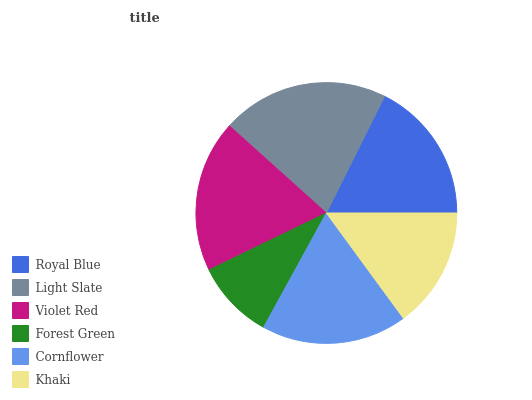Is Forest Green the minimum?
Answer yes or no. Yes. Is Light Slate the maximum?
Answer yes or no. Yes. Is Violet Red the minimum?
Answer yes or no. No. Is Violet Red the maximum?
Answer yes or no. No. Is Light Slate greater than Violet Red?
Answer yes or no. Yes. Is Violet Red less than Light Slate?
Answer yes or no. Yes. Is Violet Red greater than Light Slate?
Answer yes or no. No. Is Light Slate less than Violet Red?
Answer yes or no. No. Is Cornflower the high median?
Answer yes or no. Yes. Is Royal Blue the low median?
Answer yes or no. Yes. Is Light Slate the high median?
Answer yes or no. No. Is Light Slate the low median?
Answer yes or no. No. 